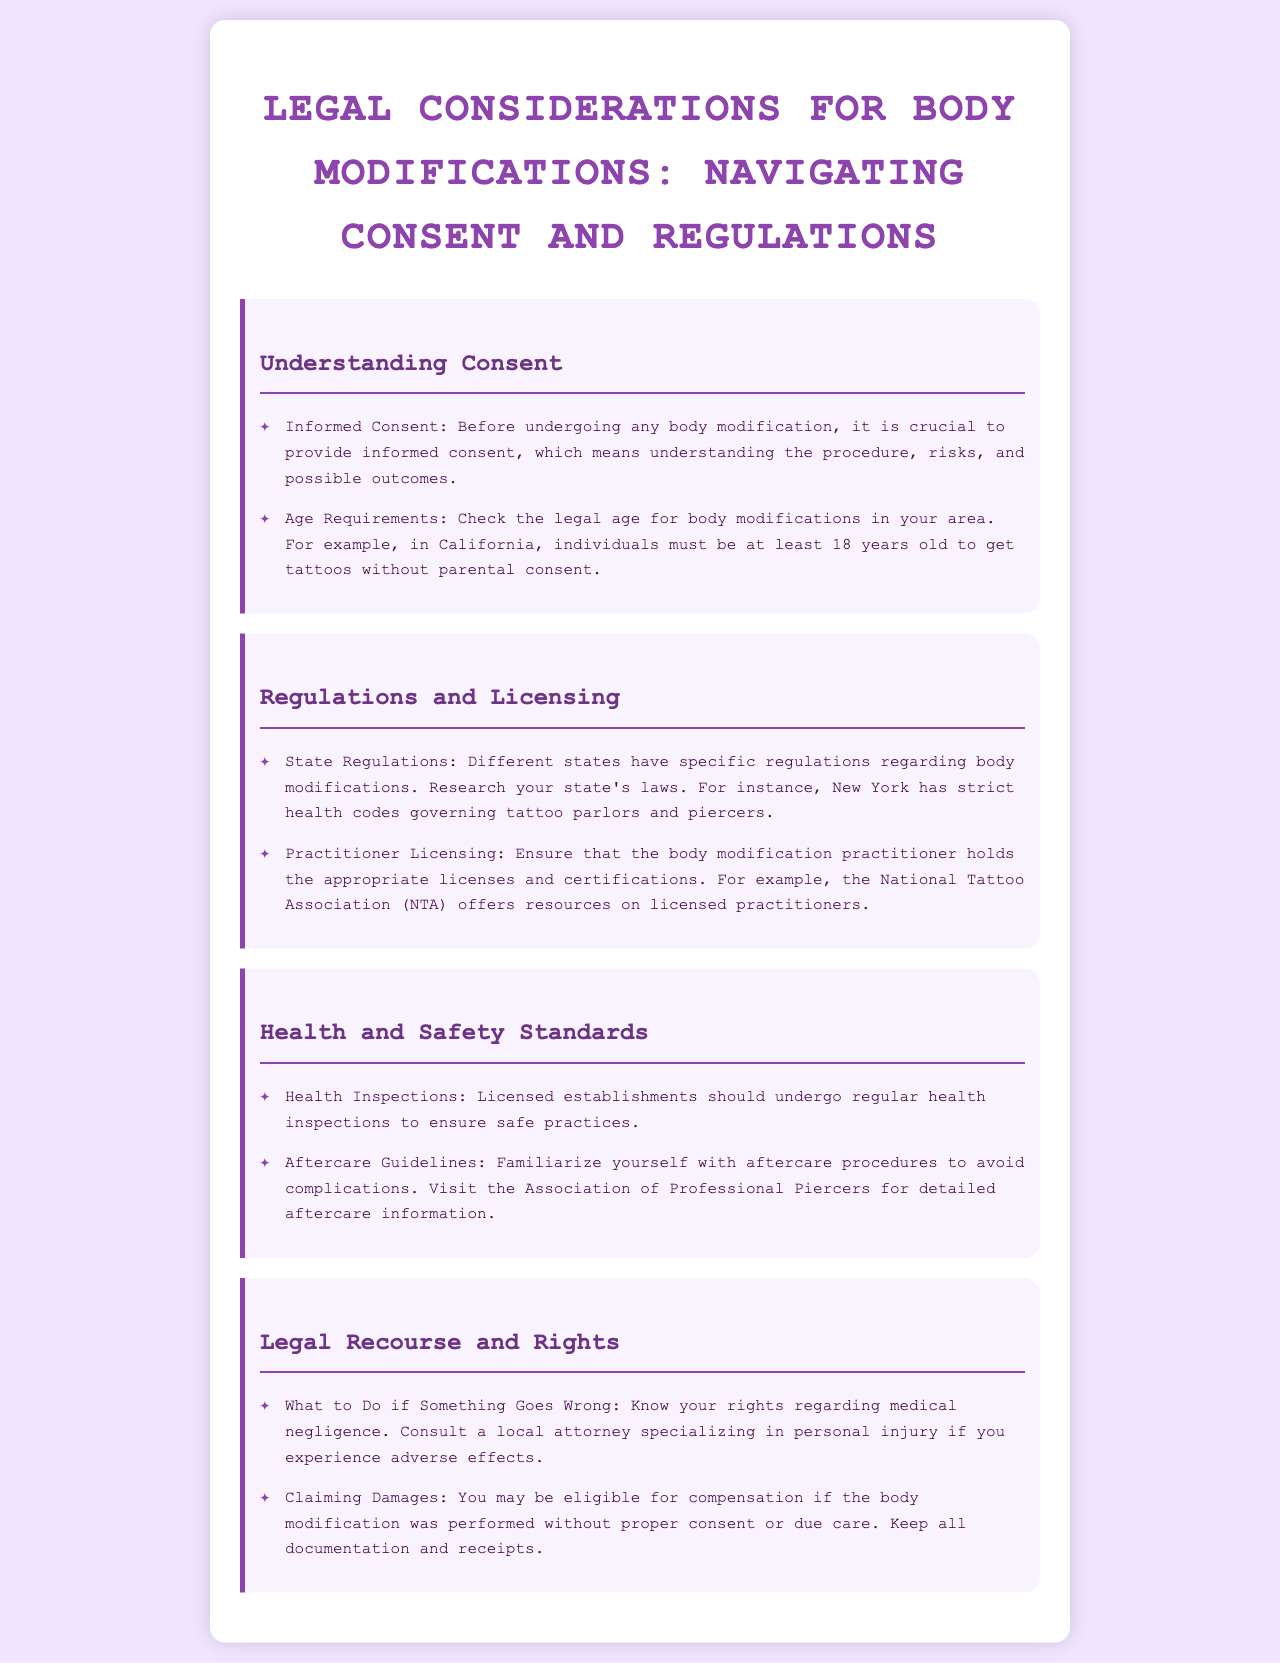What is informed consent? Informed consent means understanding the procedure, risks, and possible outcomes before undergoing any body modification.
Answer: Understanding the procedure, risks, and possible outcomes What is the legal age for tattoos in California? In California, individuals must be at least 18 years old to get tattoos without parental consent.
Answer: 18 years old Which organization offers resources on licensed practitioners? The National Tattoo Association (NTA) offers resources on licensed practitioners.
Answer: National Tattoo Association What should licensed establishments undergo regularly? Licensed establishments should undergo regular health inspections to ensure safe practices.
Answer: Regular health inspections What should you do if something goes wrong during a body modification? Consult a local attorney specializing in personal injury if you experience adverse effects.
Answer: Consult a local attorney What type of guidelines should you familiarize yourself with after a body modification? Familiarize yourself with aftercare procedures to avoid complications.
Answer: Aftercare procedures What is necessary to claim damages after a body modification? Keep all documentation and receipts if the body modification was performed without proper consent or due care.
Answer: Documentation and receipts How often do state regulations vary? Different states have specific regulations regarding body modifications.
Answer: Vary by state What is a crucial step before any body modification procedure? Providing informed consent is crucial before undergoing any body modification.
Answer: Providing informed consent 